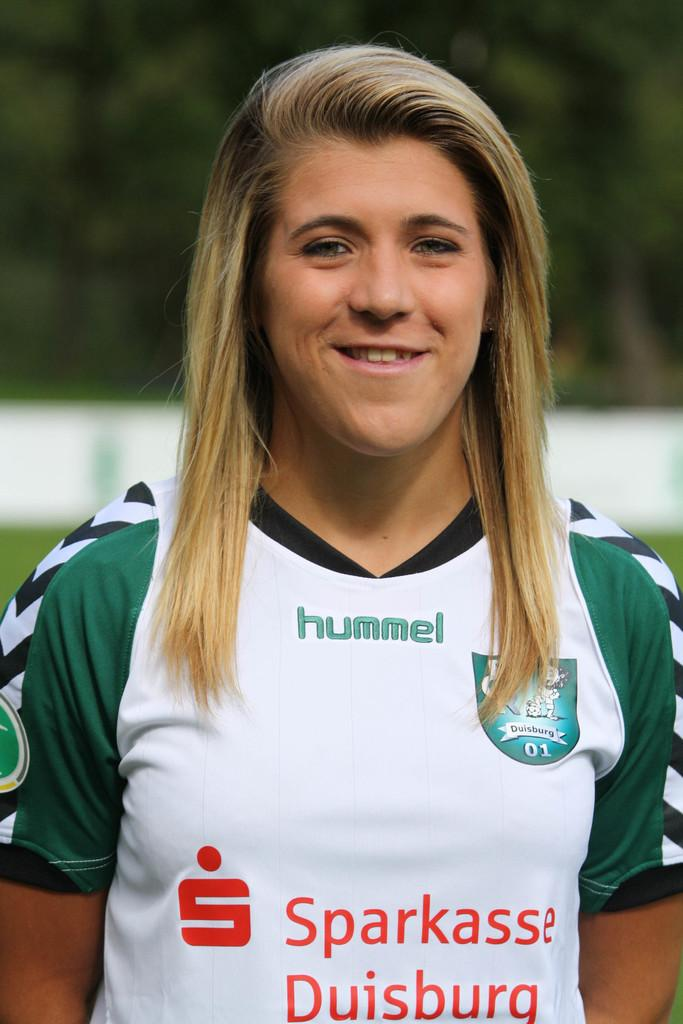<image>
Relay a brief, clear account of the picture shown. A young woman wears a t-shirt advertising Sparkasse Duisburg. 